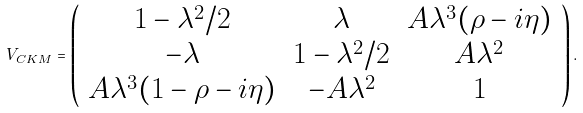Convert formula to latex. <formula><loc_0><loc_0><loc_500><loc_500>V _ { C K M } = \left ( \begin{array} { c c c } 1 - \lambda ^ { 2 } / 2 & \lambda & A \lambda ^ { 3 } ( \rho - i \eta ) \\ - \lambda & 1 - \lambda ^ { 2 } / 2 & A \lambda ^ { 2 } \\ A \lambda ^ { 3 } ( 1 - \rho - i \eta ) & - A \lambda ^ { 2 } & 1 \end{array} \right ) .</formula> 